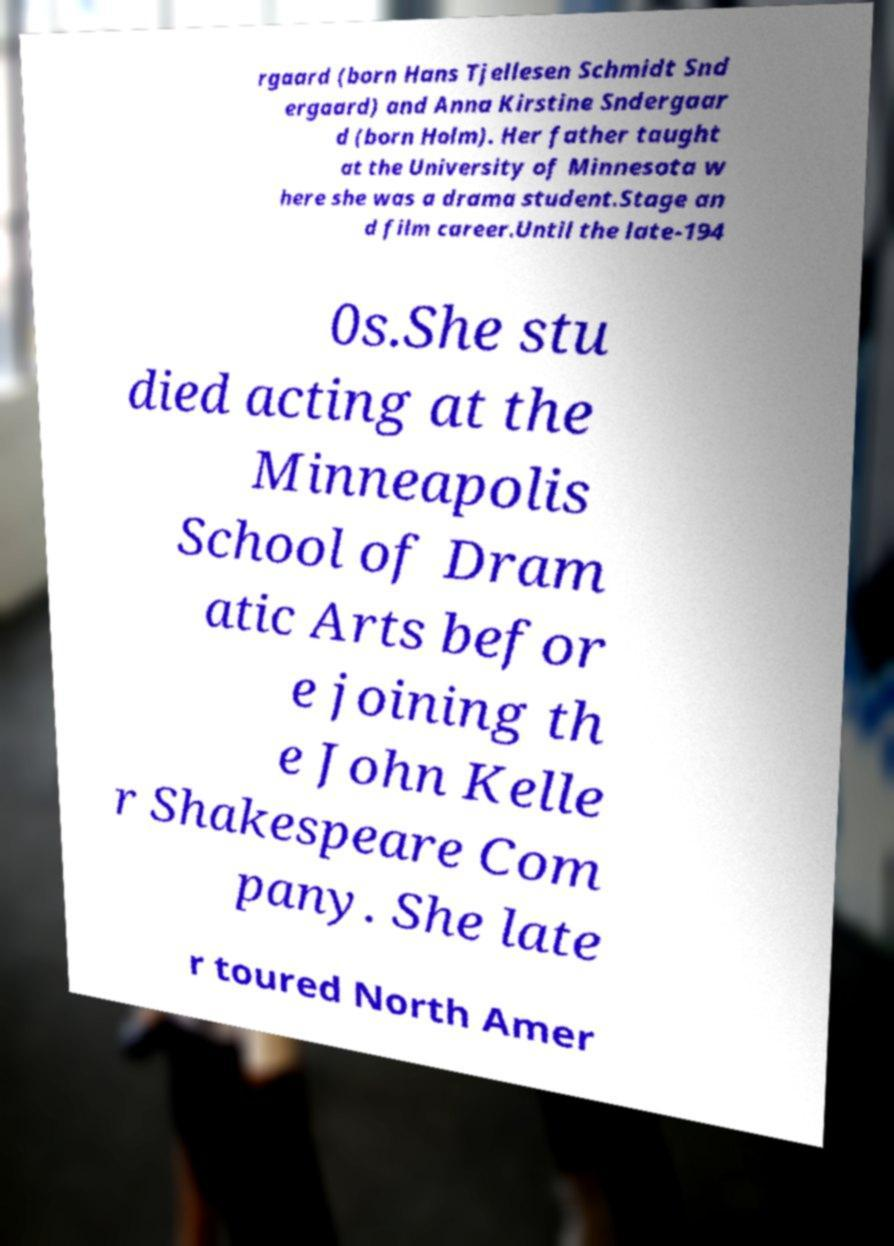Can you accurately transcribe the text from the provided image for me? rgaard (born Hans Tjellesen Schmidt Snd ergaard) and Anna Kirstine Sndergaar d (born Holm). Her father taught at the University of Minnesota w here she was a drama student.Stage an d film career.Until the late-194 0s.She stu died acting at the Minneapolis School of Dram atic Arts befor e joining th e John Kelle r Shakespeare Com pany. She late r toured North Amer 